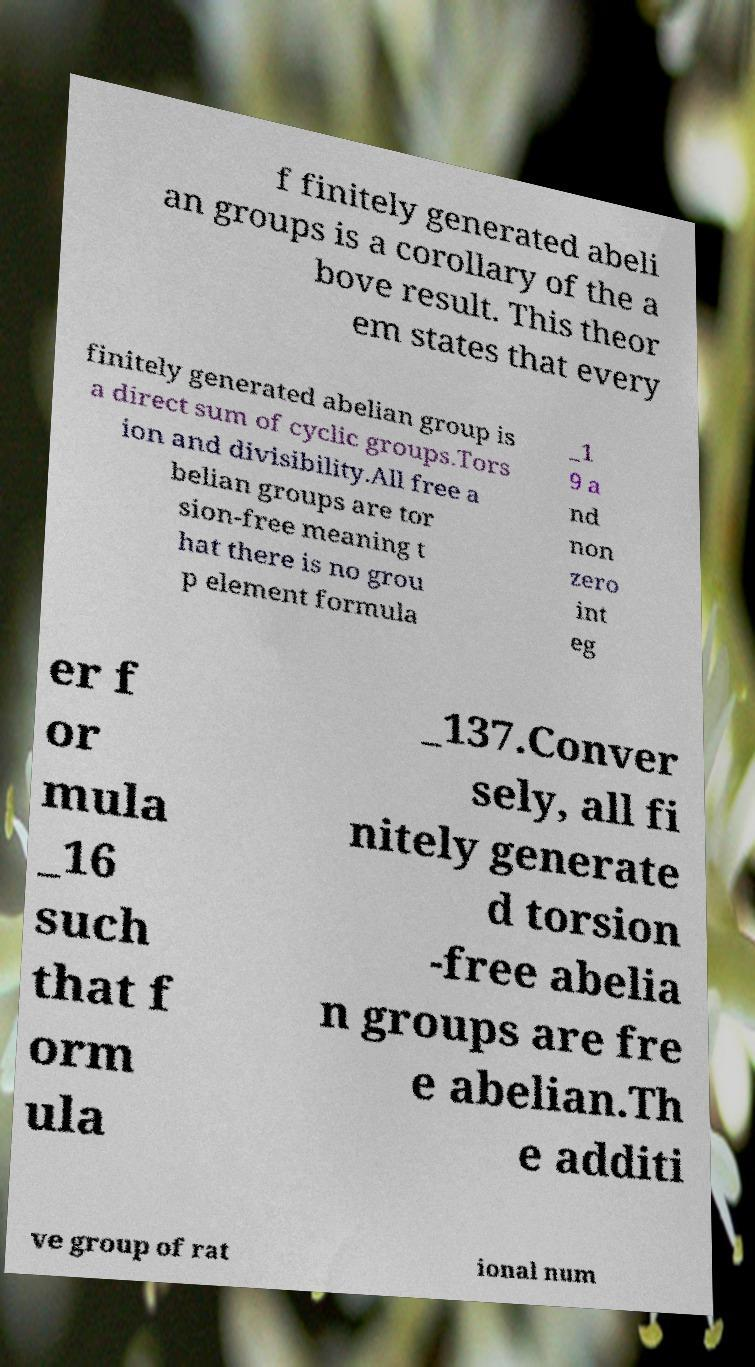Could you extract and type out the text from this image? f finitely generated abeli an groups is a corollary of the a bove result. This theor em states that every finitely generated abelian group is a direct sum of cyclic groups.Tors ion and divisibility.All free a belian groups are tor sion-free meaning t hat there is no grou p element formula _1 9 a nd non zero int eg er f or mula _16 such that f orm ula _137.Conver sely, all fi nitely generate d torsion -free abelia n groups are fre e abelian.Th e additi ve group of rat ional num 